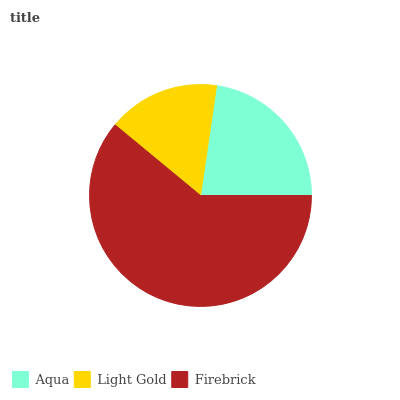Is Light Gold the minimum?
Answer yes or no. Yes. Is Firebrick the maximum?
Answer yes or no. Yes. Is Firebrick the minimum?
Answer yes or no. No. Is Light Gold the maximum?
Answer yes or no. No. Is Firebrick greater than Light Gold?
Answer yes or no. Yes. Is Light Gold less than Firebrick?
Answer yes or no. Yes. Is Light Gold greater than Firebrick?
Answer yes or no. No. Is Firebrick less than Light Gold?
Answer yes or no. No. Is Aqua the high median?
Answer yes or no. Yes. Is Aqua the low median?
Answer yes or no. Yes. Is Light Gold the high median?
Answer yes or no. No. Is Firebrick the low median?
Answer yes or no. No. 